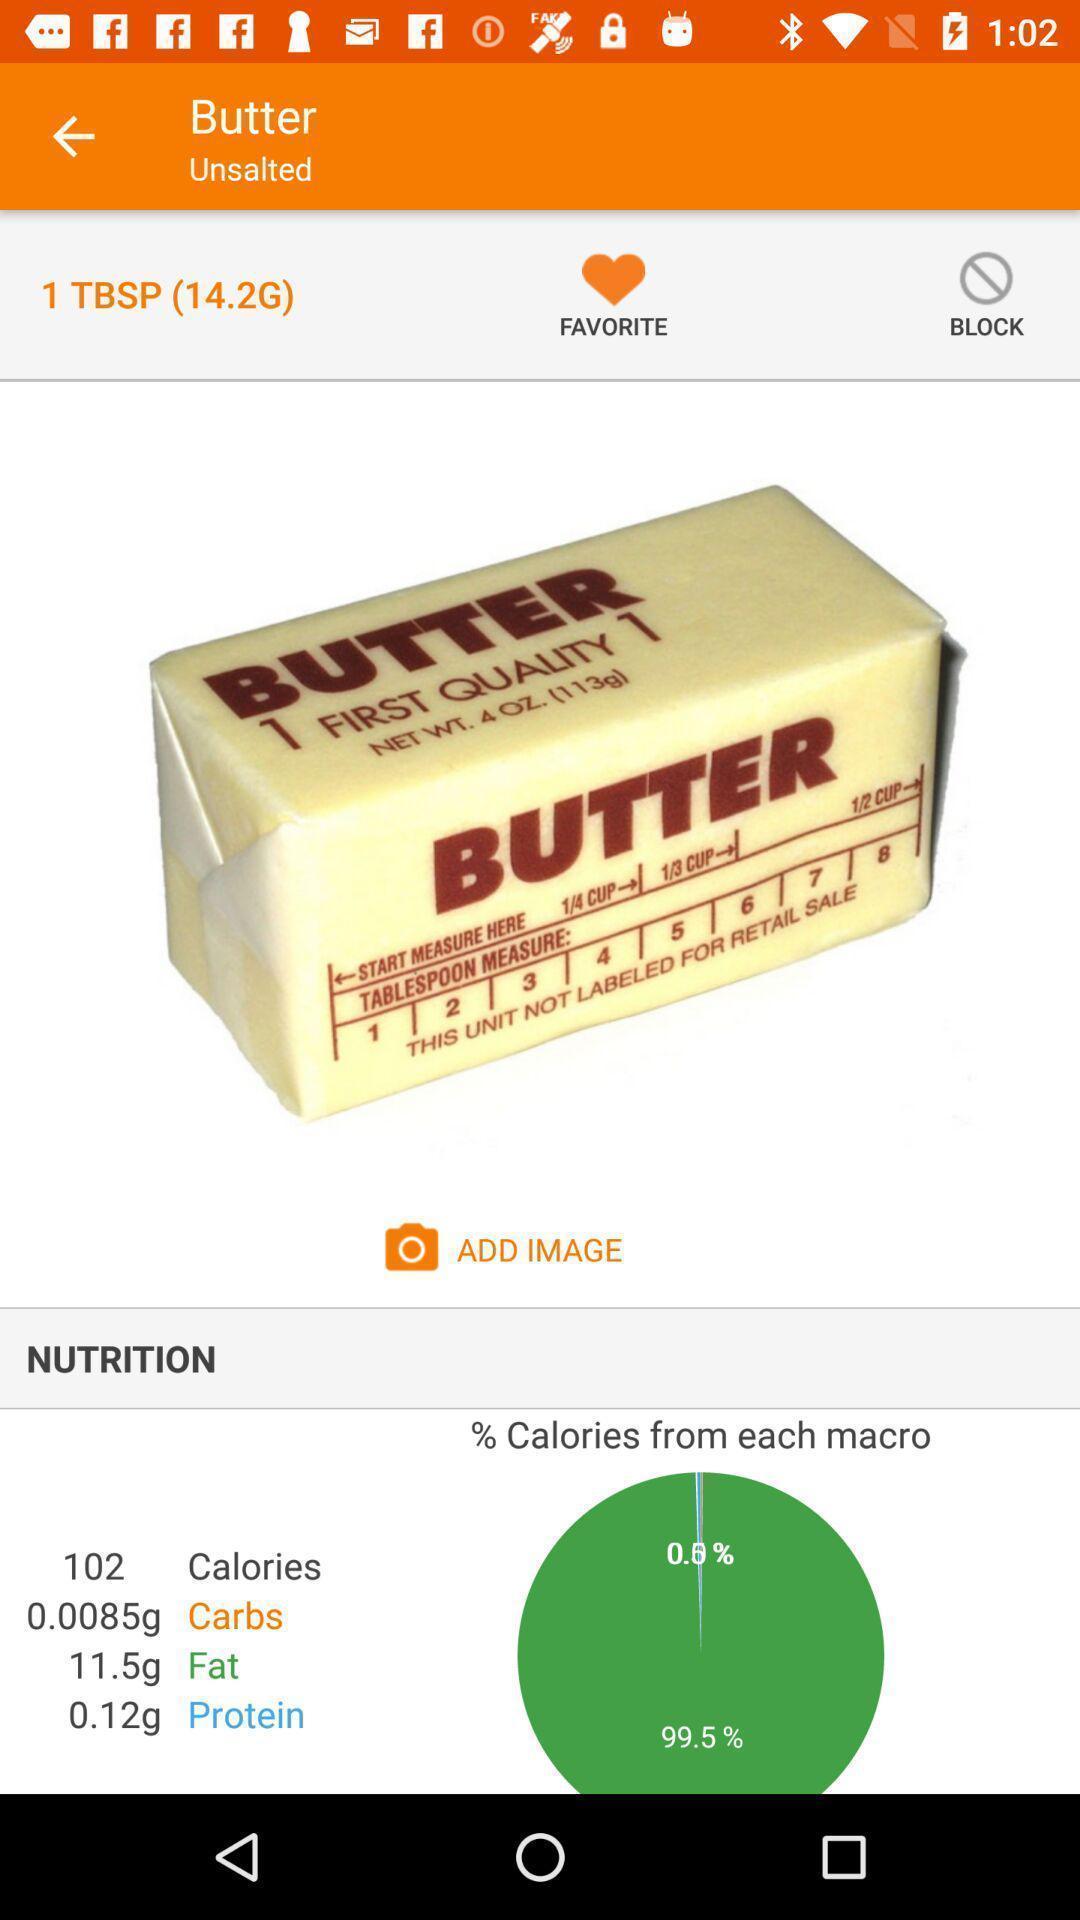Provide a detailed account of this screenshot. Screen showing nutrition. 